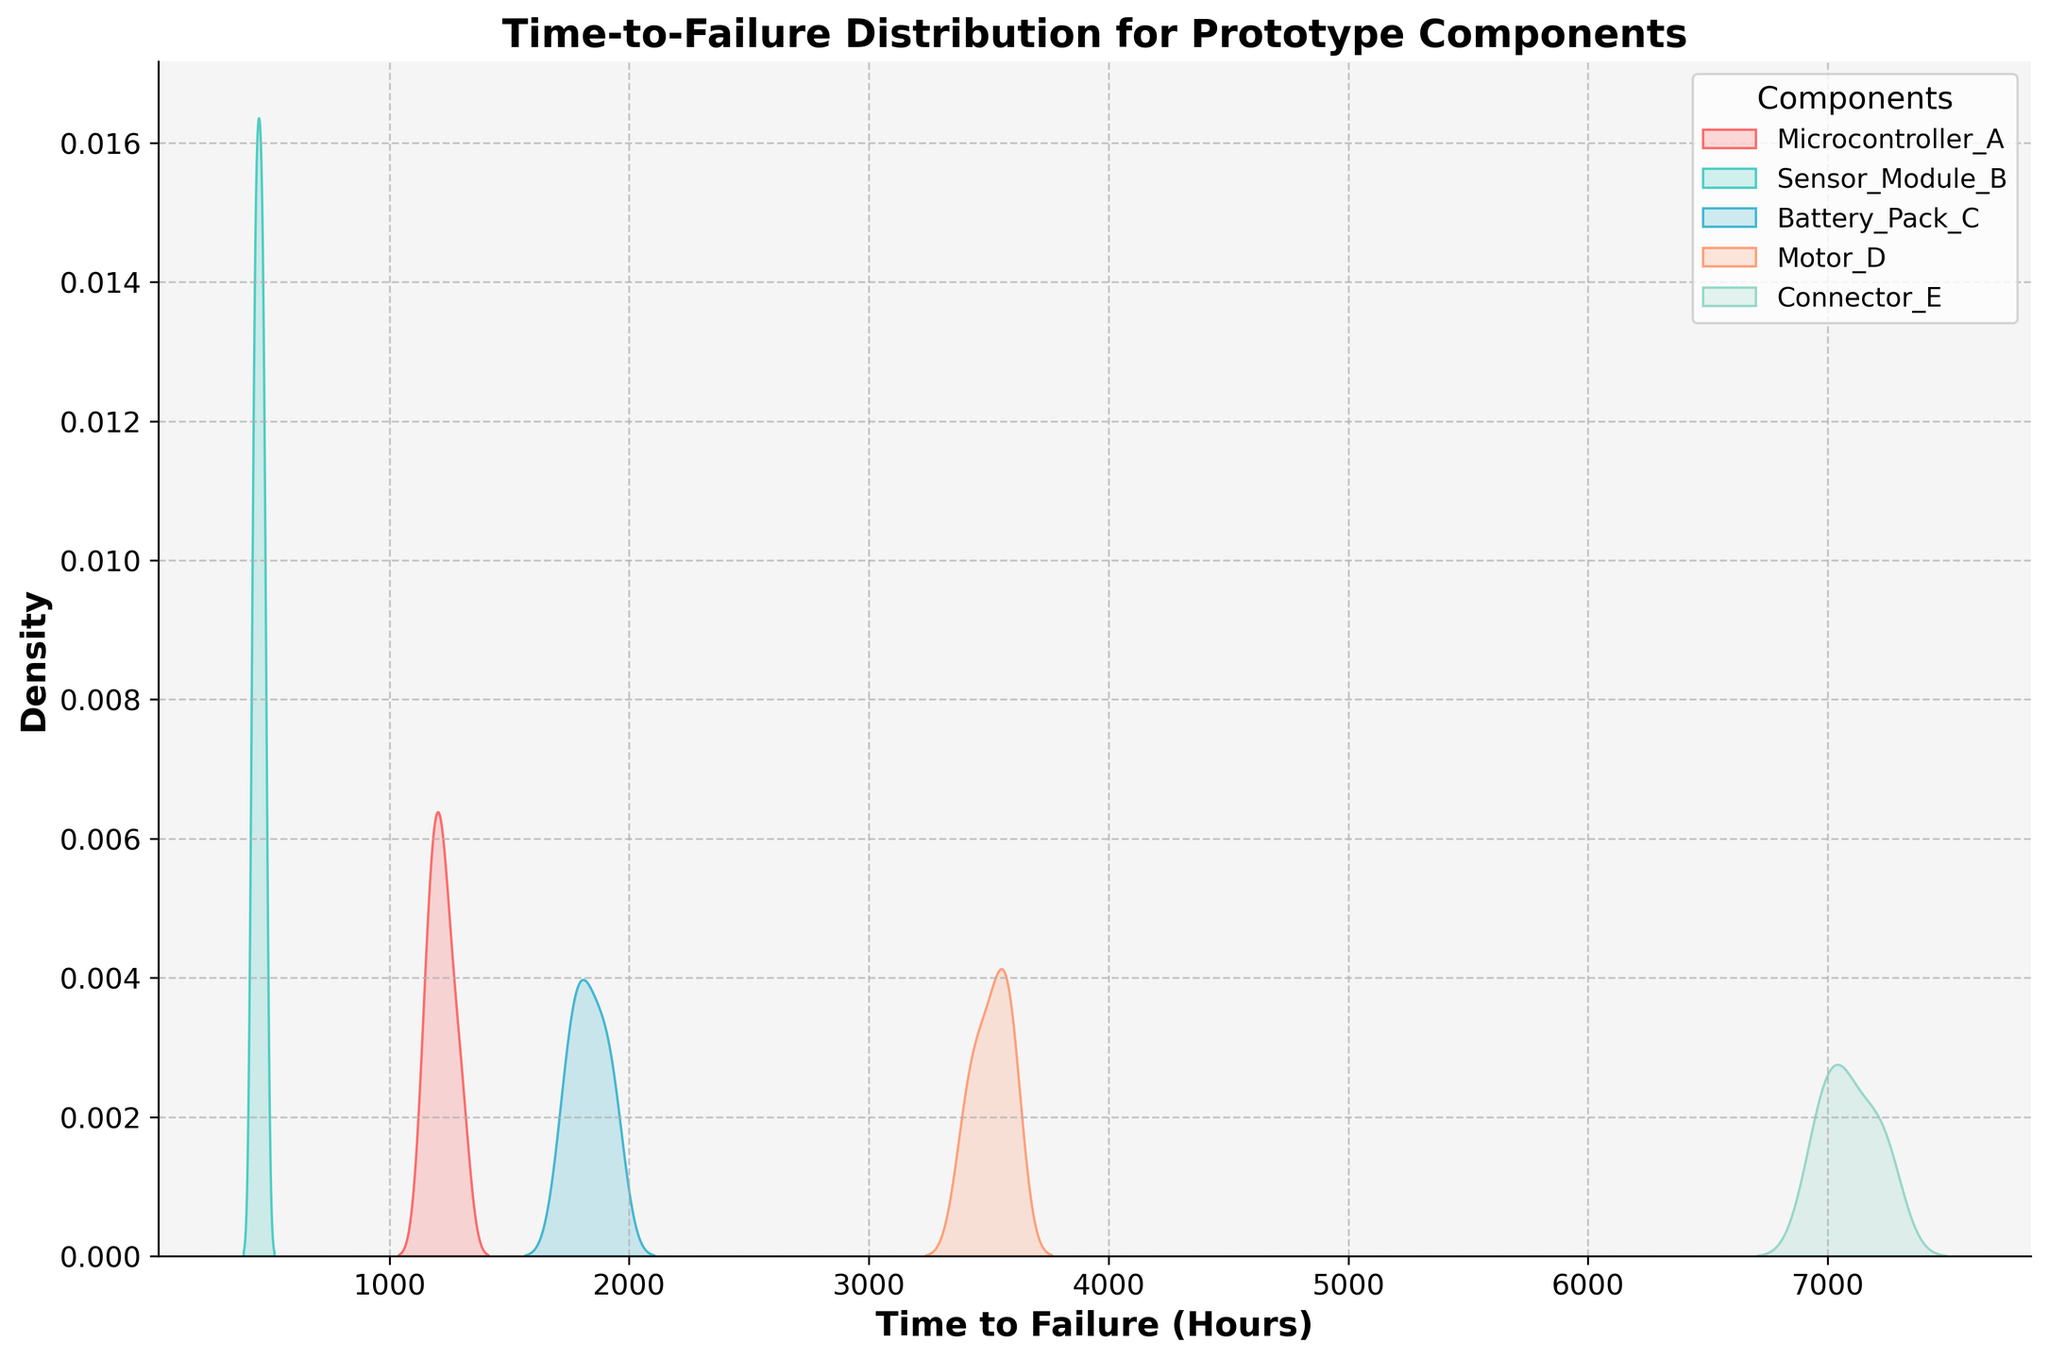what is the title of the figure? The title of the figure is located at the top center of the plot. Reading the text at the top, we see it is 'Time-to-Failure Distribution for Prototype Components'.
Answer: Time-to-Failure Distribution for Prototype Components what is shown on the x-axis? The label of the x-axis, located directly below the horizontal axis, tells us it is 'Time to Failure (Hours)'.
Answer: Time to Failure (Hours) which component has the highest peak in density? The density peaks represent the highest concentration of time-to-failure values for each component. Connector_E shows the highest peak, indicating it has the highest concentration around its time-to-failure values.
Answer: Connector_E which components have the smallest and largest time-to-failure ranges? The range of time-to-failure can be observed by the spread of the curves. Sensor_Module_B has the smallest range, tightly clustered between 430 to 480 hours, whereas Connector_E has the largest range, spread between 6950 and 7250 hours.
Answer: smallest: Sensor_Module_B, largest: Connector_E what is the difference between the peak densities of Microcontroller_A and Battery_Pack_C? Comparing the peaks visually, the density peak for Microcontroller_A is slightly higher than that of Battery_Pack_C. Estimating the difference by visual inspection, Microcontroller_A's peak density is roughly 0.002 higher than Battery_Pack_C.
Answer: 0.002 how many components are compared in the plot? The number of distinct components can be read from the legend, where each component is listed. There are five components: Microcontroller_A, Sensor_Module_B, Battery_Pack_C, Motor_D, and Connector_E.
Answer: Five which component has the broadest density distribution? The breadth or width of the density distribution curve indicates how spread out the values are. Motor_D's distribution is the broadest, stretching from around 3400 to 3600 hours.
Answer: Motor_D which components have overlapping time-to-failure ranges? Observing the curves, we see that Microcontroller_A and Battery_Pack_C have overlapping time-to-failure ranges, approximately between 1150 to 1300 hours and 1730 to 1940 hours, respectively.
Answer: Microcontroller_A and Battery_Pack_C 